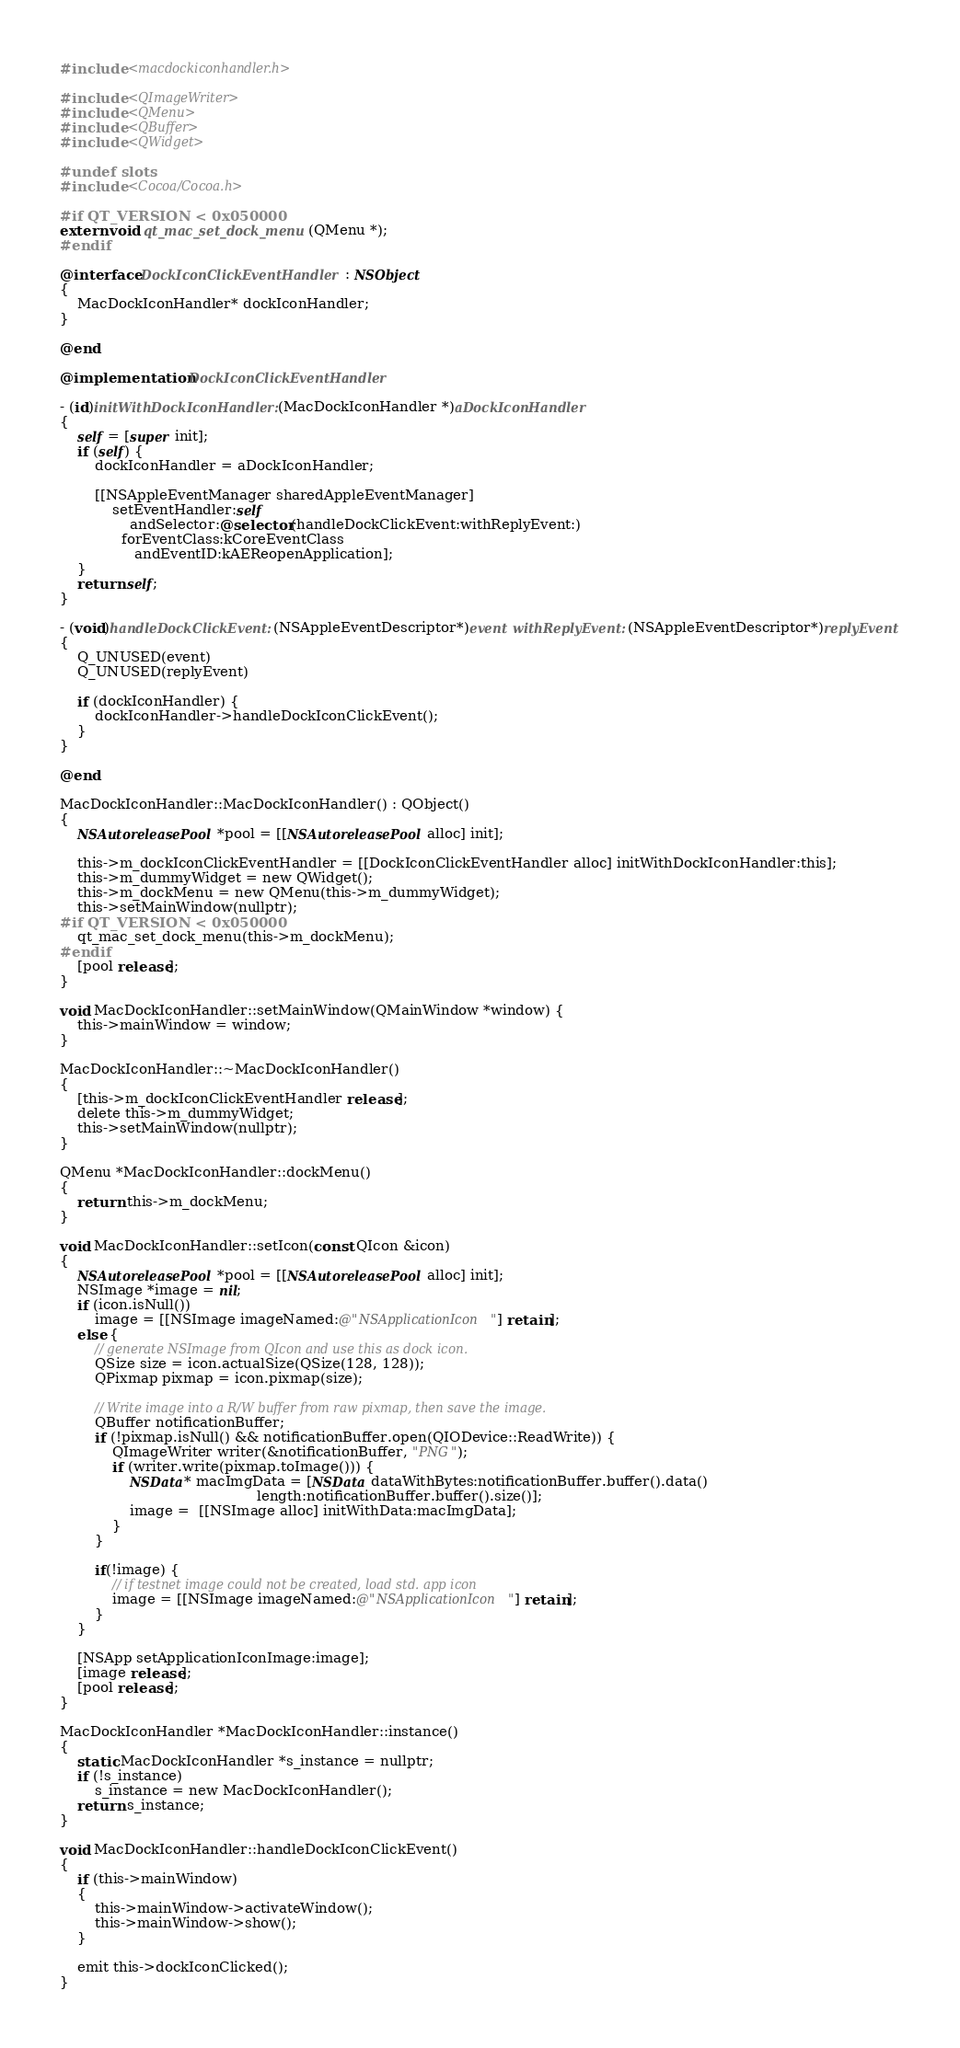Convert code to text. <code><loc_0><loc_0><loc_500><loc_500><_ObjectiveC_>#include <macdockiconhandler.h>

#include <QImageWriter>
#include <QMenu>
#include <QBuffer>
#include <QWidget>

#undef slots
#include <Cocoa/Cocoa.h>

#if QT_VERSION < 0x050000
extern void qt_mac_set_dock_menu(QMenu *);
#endif

@interface DockIconClickEventHandler : NSObject
{
    MacDockIconHandler* dockIconHandler;
}

@end

@implementation DockIconClickEventHandler

- (id)initWithDockIconHandler:(MacDockIconHandler *)aDockIconHandler
{
    self = [super init];
    if (self) {
        dockIconHandler = aDockIconHandler;

        [[NSAppleEventManager sharedAppleEventManager]
            setEventHandler:self
                andSelector:@selector(handleDockClickEvent:withReplyEvent:)
              forEventClass:kCoreEventClass
                 andEventID:kAEReopenApplication];
    }
    return self;
}

- (void)handleDockClickEvent:(NSAppleEventDescriptor*)event withReplyEvent:(NSAppleEventDescriptor*)replyEvent
{
    Q_UNUSED(event)
    Q_UNUSED(replyEvent)

    if (dockIconHandler) {
        dockIconHandler->handleDockIconClickEvent();
    }
}

@end

MacDockIconHandler::MacDockIconHandler() : QObject()
{
    NSAutoreleasePool *pool = [[NSAutoreleasePool alloc] init];

    this->m_dockIconClickEventHandler = [[DockIconClickEventHandler alloc] initWithDockIconHandler:this];
    this->m_dummyWidget = new QWidget();
    this->m_dockMenu = new QMenu(this->m_dummyWidget);
    this->setMainWindow(nullptr);
#if QT_VERSION < 0x050000
    qt_mac_set_dock_menu(this->m_dockMenu);
#endif
    [pool release];
}

void MacDockIconHandler::setMainWindow(QMainWindow *window) {
    this->mainWindow = window;
}

MacDockIconHandler::~MacDockIconHandler()
{
    [this->m_dockIconClickEventHandler release];
    delete this->m_dummyWidget;
    this->setMainWindow(nullptr);
}

QMenu *MacDockIconHandler::dockMenu()
{
    return this->m_dockMenu;
}

void MacDockIconHandler::setIcon(const QIcon &icon)
{
    NSAutoreleasePool *pool = [[NSAutoreleasePool alloc] init];
    NSImage *image = nil;
    if (icon.isNull())
        image = [[NSImage imageNamed:@"NSApplicationIcon"] retain];
    else {
        // generate NSImage from QIcon and use this as dock icon.
        QSize size = icon.actualSize(QSize(128, 128));
        QPixmap pixmap = icon.pixmap(size);

        // Write image into a R/W buffer from raw pixmap, then save the image.
        QBuffer notificationBuffer;
        if (!pixmap.isNull() && notificationBuffer.open(QIODevice::ReadWrite)) {
            QImageWriter writer(&notificationBuffer, "PNG");
            if (writer.write(pixmap.toImage())) {
                NSData* macImgData = [NSData dataWithBytes:notificationBuffer.buffer().data()
                                             length:notificationBuffer.buffer().size()];
                image =  [[NSImage alloc] initWithData:macImgData];
            }
        }

        if(!image) {
            // if testnet image could not be created, load std. app icon
            image = [[NSImage imageNamed:@"NSApplicationIcon"] retain];
        }
    }

    [NSApp setApplicationIconImage:image];
    [image release];
    [pool release];
}

MacDockIconHandler *MacDockIconHandler::instance()
{
    static MacDockIconHandler *s_instance = nullptr;
    if (!s_instance)
        s_instance = new MacDockIconHandler();
    return s_instance;
}

void MacDockIconHandler::handleDockIconClickEvent()
{
    if (this->mainWindow)
    {
        this->mainWindow->activateWindow();
        this->mainWindow->show();
    }

    emit this->dockIconClicked();
}
</code> 